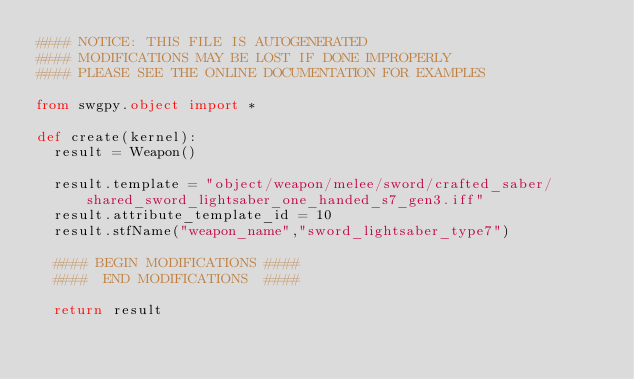<code> <loc_0><loc_0><loc_500><loc_500><_Python_>#### NOTICE: THIS FILE IS AUTOGENERATED
#### MODIFICATIONS MAY BE LOST IF DONE IMPROPERLY
#### PLEASE SEE THE ONLINE DOCUMENTATION FOR EXAMPLES

from swgpy.object import *	

def create(kernel):
	result = Weapon()

	result.template = "object/weapon/melee/sword/crafted_saber/shared_sword_lightsaber_one_handed_s7_gen3.iff"
	result.attribute_template_id = 10
	result.stfName("weapon_name","sword_lightsaber_type7")		
	
	#### BEGIN MODIFICATIONS ####
	####  END MODIFICATIONS  ####
	
	return result</code> 